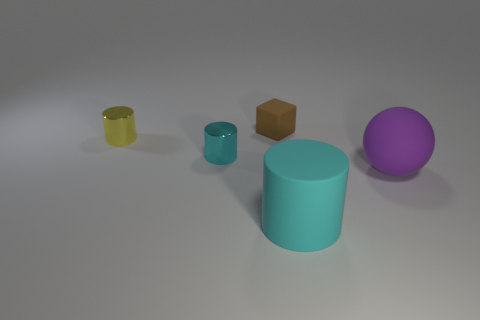Add 2 big purple objects. How many objects exist? 7 Subtract all cylinders. How many objects are left? 2 Subtract all tiny yellow objects. Subtract all purple spheres. How many objects are left? 3 Add 4 small matte objects. How many small matte objects are left? 5 Add 3 big gray matte balls. How many big gray matte balls exist? 3 Subtract 0 red spheres. How many objects are left? 5 